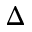Convert formula to latex. <formula><loc_0><loc_0><loc_500><loc_500>\Delta</formula> 